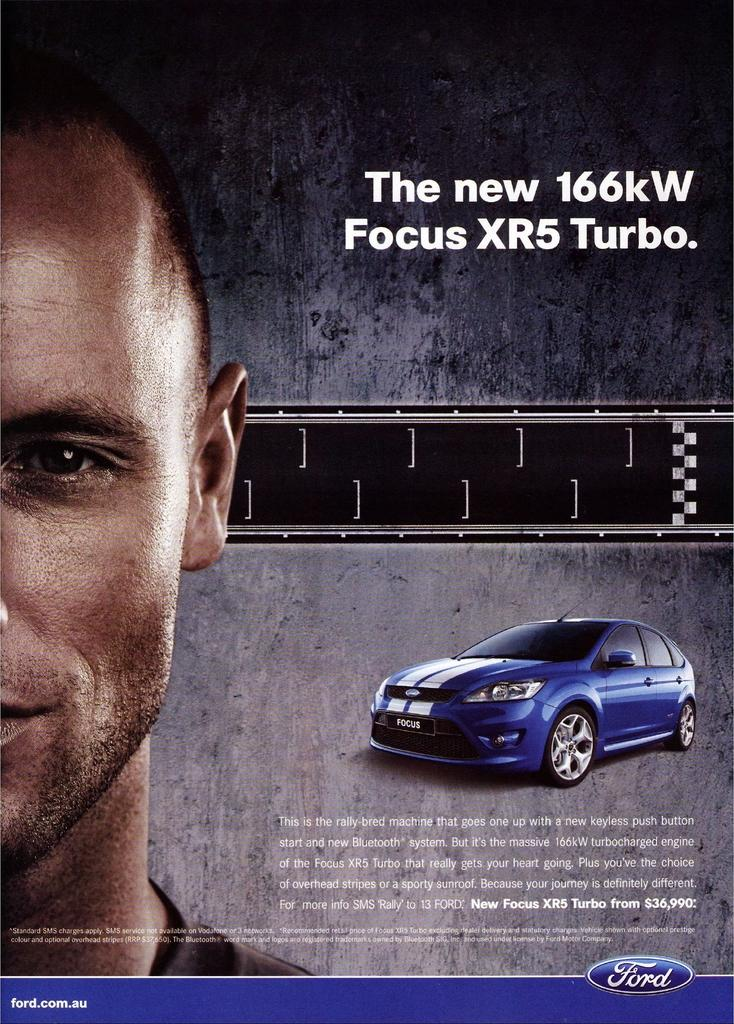What is depicted on the poster in the image? The poster features a face of a person. What type of vehicle can be seen in the image? There is a blue car in the image. What is above the blue car in the image? There is a road above the blue car. Are there any words or letters in the image? Yes, some text is written in the image. What type of vessel is being used by the spy in the image? There is no vessel or spy present in the image. What kind of ball is being used by the person in the image? There is no ball present in the image. 